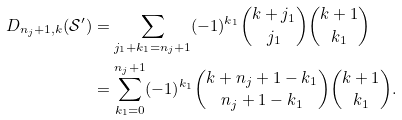<formula> <loc_0><loc_0><loc_500><loc_500>D _ { n _ { j } + 1 , k } ( \mathcal { S } ^ { \prime } ) & = \sum _ { j _ { 1 } + k _ { 1 } = n _ { j } + 1 } ( - 1 ) ^ { k _ { 1 } } \binom { k + j _ { 1 } } { j _ { 1 } } \binom { k + 1 } { k _ { 1 } } \\ & = \sum _ { k _ { 1 } = 0 } ^ { n _ { j } + 1 } ( - 1 ) ^ { k _ { 1 } } \binom { k + n _ { j } + 1 - k _ { 1 } } { n _ { j } + 1 - k _ { 1 } } \binom { k + 1 } { k _ { 1 } } . \\</formula> 